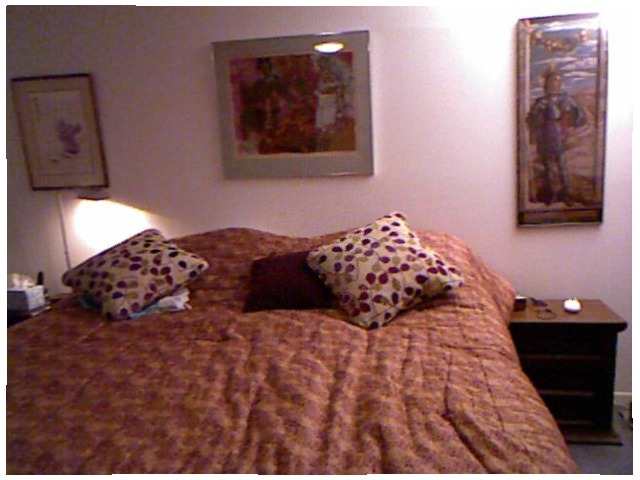<image>
Is there a photo frame under the bed? No. The photo frame is not positioned under the bed. The vertical relationship between these objects is different. 